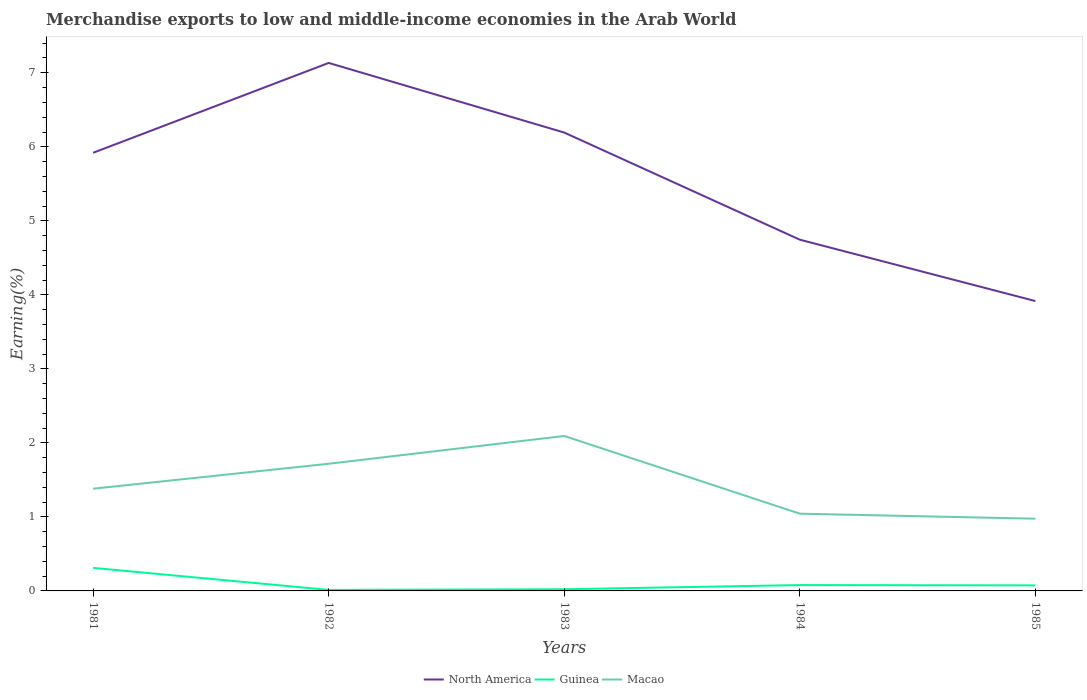Does the line corresponding to Macao intersect with the line corresponding to North America?
Provide a short and direct response. No. Across all years, what is the maximum percentage of amount earned from merchandise exports in Guinea?
Keep it short and to the point. 0.01. What is the total percentage of amount earned from merchandise exports in North America in the graph?
Offer a terse response. 0.83. What is the difference between the highest and the second highest percentage of amount earned from merchandise exports in Macao?
Your answer should be very brief. 1.12. What is the difference between the highest and the lowest percentage of amount earned from merchandise exports in Macao?
Your answer should be very brief. 2. Are the values on the major ticks of Y-axis written in scientific E-notation?
Your answer should be compact. No. Does the graph contain any zero values?
Offer a terse response. No. Does the graph contain grids?
Provide a short and direct response. No. Where does the legend appear in the graph?
Your answer should be compact. Bottom center. How many legend labels are there?
Keep it short and to the point. 3. What is the title of the graph?
Give a very brief answer. Merchandise exports to low and middle-income economies in the Arab World. Does "Bermuda" appear as one of the legend labels in the graph?
Keep it short and to the point. No. What is the label or title of the X-axis?
Make the answer very short. Years. What is the label or title of the Y-axis?
Offer a very short reply. Earning(%). What is the Earning(%) in North America in 1981?
Make the answer very short. 5.92. What is the Earning(%) of Guinea in 1981?
Offer a very short reply. 0.31. What is the Earning(%) of Macao in 1981?
Your answer should be very brief. 1.38. What is the Earning(%) of North America in 1982?
Keep it short and to the point. 7.13. What is the Earning(%) of Guinea in 1982?
Ensure brevity in your answer.  0.01. What is the Earning(%) of Macao in 1982?
Give a very brief answer. 1.72. What is the Earning(%) of North America in 1983?
Offer a terse response. 6.19. What is the Earning(%) of Guinea in 1983?
Your answer should be compact. 0.02. What is the Earning(%) in Macao in 1983?
Your answer should be compact. 2.09. What is the Earning(%) of North America in 1984?
Provide a succinct answer. 4.75. What is the Earning(%) in Guinea in 1984?
Your answer should be very brief. 0.08. What is the Earning(%) in Macao in 1984?
Offer a very short reply. 1.04. What is the Earning(%) in North America in 1985?
Keep it short and to the point. 3.92. What is the Earning(%) in Guinea in 1985?
Ensure brevity in your answer.  0.07. What is the Earning(%) of Macao in 1985?
Offer a very short reply. 0.98. Across all years, what is the maximum Earning(%) of North America?
Offer a terse response. 7.13. Across all years, what is the maximum Earning(%) of Guinea?
Provide a short and direct response. 0.31. Across all years, what is the maximum Earning(%) of Macao?
Make the answer very short. 2.09. Across all years, what is the minimum Earning(%) of North America?
Provide a short and direct response. 3.92. Across all years, what is the minimum Earning(%) of Guinea?
Provide a short and direct response. 0.01. Across all years, what is the minimum Earning(%) of Macao?
Give a very brief answer. 0.98. What is the total Earning(%) of North America in the graph?
Provide a succinct answer. 27.91. What is the total Earning(%) in Guinea in the graph?
Give a very brief answer. 0.5. What is the total Earning(%) of Macao in the graph?
Make the answer very short. 7.21. What is the difference between the Earning(%) in North America in 1981 and that in 1982?
Your answer should be compact. -1.21. What is the difference between the Earning(%) of Guinea in 1981 and that in 1982?
Provide a succinct answer. 0.3. What is the difference between the Earning(%) in Macao in 1981 and that in 1982?
Your answer should be very brief. -0.34. What is the difference between the Earning(%) of North America in 1981 and that in 1983?
Provide a succinct answer. -0.27. What is the difference between the Earning(%) of Guinea in 1981 and that in 1983?
Keep it short and to the point. 0.29. What is the difference between the Earning(%) in Macao in 1981 and that in 1983?
Provide a short and direct response. -0.71. What is the difference between the Earning(%) in North America in 1981 and that in 1984?
Your response must be concise. 1.17. What is the difference between the Earning(%) of Guinea in 1981 and that in 1984?
Provide a short and direct response. 0.23. What is the difference between the Earning(%) of Macao in 1981 and that in 1984?
Give a very brief answer. 0.34. What is the difference between the Earning(%) of North America in 1981 and that in 1985?
Offer a very short reply. 2. What is the difference between the Earning(%) in Guinea in 1981 and that in 1985?
Your response must be concise. 0.24. What is the difference between the Earning(%) in Macao in 1981 and that in 1985?
Your answer should be very brief. 0.41. What is the difference between the Earning(%) of North America in 1982 and that in 1983?
Provide a succinct answer. 0.94. What is the difference between the Earning(%) in Guinea in 1982 and that in 1983?
Your response must be concise. -0.01. What is the difference between the Earning(%) of Macao in 1982 and that in 1983?
Your answer should be very brief. -0.38. What is the difference between the Earning(%) in North America in 1982 and that in 1984?
Ensure brevity in your answer.  2.39. What is the difference between the Earning(%) in Guinea in 1982 and that in 1984?
Provide a succinct answer. -0.07. What is the difference between the Earning(%) in Macao in 1982 and that in 1984?
Give a very brief answer. 0.67. What is the difference between the Earning(%) of North America in 1982 and that in 1985?
Make the answer very short. 3.22. What is the difference between the Earning(%) of Guinea in 1982 and that in 1985?
Make the answer very short. -0.06. What is the difference between the Earning(%) of Macao in 1982 and that in 1985?
Offer a terse response. 0.74. What is the difference between the Earning(%) in North America in 1983 and that in 1984?
Provide a succinct answer. 1.45. What is the difference between the Earning(%) of Guinea in 1983 and that in 1984?
Your answer should be very brief. -0.06. What is the difference between the Earning(%) in Macao in 1983 and that in 1984?
Ensure brevity in your answer.  1.05. What is the difference between the Earning(%) in North America in 1983 and that in 1985?
Make the answer very short. 2.28. What is the difference between the Earning(%) in Guinea in 1983 and that in 1985?
Ensure brevity in your answer.  -0.05. What is the difference between the Earning(%) in Macao in 1983 and that in 1985?
Provide a short and direct response. 1.12. What is the difference between the Earning(%) of North America in 1984 and that in 1985?
Ensure brevity in your answer.  0.83. What is the difference between the Earning(%) of Guinea in 1984 and that in 1985?
Make the answer very short. 0. What is the difference between the Earning(%) in Macao in 1984 and that in 1985?
Provide a short and direct response. 0.07. What is the difference between the Earning(%) in North America in 1981 and the Earning(%) in Guinea in 1982?
Your answer should be very brief. 5.91. What is the difference between the Earning(%) in North America in 1981 and the Earning(%) in Macao in 1982?
Offer a very short reply. 4.2. What is the difference between the Earning(%) of Guinea in 1981 and the Earning(%) of Macao in 1982?
Provide a short and direct response. -1.41. What is the difference between the Earning(%) of North America in 1981 and the Earning(%) of Guinea in 1983?
Offer a very short reply. 5.9. What is the difference between the Earning(%) in North America in 1981 and the Earning(%) in Macao in 1983?
Provide a succinct answer. 3.83. What is the difference between the Earning(%) in Guinea in 1981 and the Earning(%) in Macao in 1983?
Provide a short and direct response. -1.78. What is the difference between the Earning(%) of North America in 1981 and the Earning(%) of Guinea in 1984?
Provide a succinct answer. 5.84. What is the difference between the Earning(%) of North America in 1981 and the Earning(%) of Macao in 1984?
Your response must be concise. 4.88. What is the difference between the Earning(%) of Guinea in 1981 and the Earning(%) of Macao in 1984?
Keep it short and to the point. -0.73. What is the difference between the Earning(%) in North America in 1981 and the Earning(%) in Guinea in 1985?
Offer a terse response. 5.84. What is the difference between the Earning(%) of North America in 1981 and the Earning(%) of Macao in 1985?
Your answer should be compact. 4.94. What is the difference between the Earning(%) in Guinea in 1981 and the Earning(%) in Macao in 1985?
Give a very brief answer. -0.66. What is the difference between the Earning(%) in North America in 1982 and the Earning(%) in Guinea in 1983?
Keep it short and to the point. 7.11. What is the difference between the Earning(%) in North America in 1982 and the Earning(%) in Macao in 1983?
Provide a short and direct response. 5.04. What is the difference between the Earning(%) in Guinea in 1982 and the Earning(%) in Macao in 1983?
Offer a terse response. -2.08. What is the difference between the Earning(%) of North America in 1982 and the Earning(%) of Guinea in 1984?
Ensure brevity in your answer.  7.05. What is the difference between the Earning(%) in North America in 1982 and the Earning(%) in Macao in 1984?
Give a very brief answer. 6.09. What is the difference between the Earning(%) of Guinea in 1982 and the Earning(%) of Macao in 1984?
Offer a terse response. -1.03. What is the difference between the Earning(%) in North America in 1982 and the Earning(%) in Guinea in 1985?
Give a very brief answer. 7.06. What is the difference between the Earning(%) in North America in 1982 and the Earning(%) in Macao in 1985?
Your response must be concise. 6.16. What is the difference between the Earning(%) of Guinea in 1982 and the Earning(%) of Macao in 1985?
Your answer should be compact. -0.96. What is the difference between the Earning(%) of North America in 1983 and the Earning(%) of Guinea in 1984?
Provide a succinct answer. 6.11. What is the difference between the Earning(%) in North America in 1983 and the Earning(%) in Macao in 1984?
Make the answer very short. 5.15. What is the difference between the Earning(%) of Guinea in 1983 and the Earning(%) of Macao in 1984?
Keep it short and to the point. -1.02. What is the difference between the Earning(%) of North America in 1983 and the Earning(%) of Guinea in 1985?
Your response must be concise. 6.12. What is the difference between the Earning(%) in North America in 1983 and the Earning(%) in Macao in 1985?
Offer a very short reply. 5.22. What is the difference between the Earning(%) in Guinea in 1983 and the Earning(%) in Macao in 1985?
Give a very brief answer. -0.95. What is the difference between the Earning(%) of North America in 1984 and the Earning(%) of Guinea in 1985?
Your answer should be very brief. 4.67. What is the difference between the Earning(%) in North America in 1984 and the Earning(%) in Macao in 1985?
Offer a terse response. 3.77. What is the difference between the Earning(%) in Guinea in 1984 and the Earning(%) in Macao in 1985?
Your response must be concise. -0.9. What is the average Earning(%) of North America per year?
Provide a succinct answer. 5.58. What is the average Earning(%) of Guinea per year?
Provide a succinct answer. 0.1. What is the average Earning(%) of Macao per year?
Give a very brief answer. 1.44. In the year 1981, what is the difference between the Earning(%) of North America and Earning(%) of Guinea?
Keep it short and to the point. 5.61. In the year 1981, what is the difference between the Earning(%) of North America and Earning(%) of Macao?
Offer a very short reply. 4.54. In the year 1981, what is the difference between the Earning(%) in Guinea and Earning(%) in Macao?
Provide a short and direct response. -1.07. In the year 1982, what is the difference between the Earning(%) of North America and Earning(%) of Guinea?
Offer a terse response. 7.12. In the year 1982, what is the difference between the Earning(%) of North America and Earning(%) of Macao?
Give a very brief answer. 5.42. In the year 1982, what is the difference between the Earning(%) in Guinea and Earning(%) in Macao?
Provide a succinct answer. -1.7. In the year 1983, what is the difference between the Earning(%) in North America and Earning(%) in Guinea?
Your response must be concise. 6.17. In the year 1983, what is the difference between the Earning(%) in North America and Earning(%) in Macao?
Offer a terse response. 4.1. In the year 1983, what is the difference between the Earning(%) in Guinea and Earning(%) in Macao?
Make the answer very short. -2.07. In the year 1984, what is the difference between the Earning(%) of North America and Earning(%) of Guinea?
Provide a short and direct response. 4.67. In the year 1984, what is the difference between the Earning(%) in North America and Earning(%) in Macao?
Keep it short and to the point. 3.7. In the year 1984, what is the difference between the Earning(%) of Guinea and Earning(%) of Macao?
Give a very brief answer. -0.96. In the year 1985, what is the difference between the Earning(%) of North America and Earning(%) of Guinea?
Provide a short and direct response. 3.84. In the year 1985, what is the difference between the Earning(%) in North America and Earning(%) in Macao?
Ensure brevity in your answer.  2.94. In the year 1985, what is the difference between the Earning(%) in Guinea and Earning(%) in Macao?
Provide a succinct answer. -0.9. What is the ratio of the Earning(%) of North America in 1981 to that in 1982?
Provide a succinct answer. 0.83. What is the ratio of the Earning(%) in Guinea in 1981 to that in 1982?
Provide a short and direct response. 22.32. What is the ratio of the Earning(%) of Macao in 1981 to that in 1982?
Your response must be concise. 0.8. What is the ratio of the Earning(%) in North America in 1981 to that in 1983?
Your response must be concise. 0.96. What is the ratio of the Earning(%) of Guinea in 1981 to that in 1983?
Ensure brevity in your answer.  13.79. What is the ratio of the Earning(%) in Macao in 1981 to that in 1983?
Your response must be concise. 0.66. What is the ratio of the Earning(%) in North America in 1981 to that in 1984?
Ensure brevity in your answer.  1.25. What is the ratio of the Earning(%) in Guinea in 1981 to that in 1984?
Ensure brevity in your answer.  3.93. What is the ratio of the Earning(%) in Macao in 1981 to that in 1984?
Provide a short and direct response. 1.32. What is the ratio of the Earning(%) in North America in 1981 to that in 1985?
Ensure brevity in your answer.  1.51. What is the ratio of the Earning(%) in Guinea in 1981 to that in 1985?
Offer a terse response. 4.16. What is the ratio of the Earning(%) of Macao in 1981 to that in 1985?
Offer a very short reply. 1.42. What is the ratio of the Earning(%) of North America in 1982 to that in 1983?
Provide a short and direct response. 1.15. What is the ratio of the Earning(%) in Guinea in 1982 to that in 1983?
Your answer should be very brief. 0.62. What is the ratio of the Earning(%) in Macao in 1982 to that in 1983?
Your answer should be very brief. 0.82. What is the ratio of the Earning(%) in North America in 1982 to that in 1984?
Give a very brief answer. 1.5. What is the ratio of the Earning(%) of Guinea in 1982 to that in 1984?
Offer a very short reply. 0.18. What is the ratio of the Earning(%) in Macao in 1982 to that in 1984?
Provide a short and direct response. 1.65. What is the ratio of the Earning(%) in North America in 1982 to that in 1985?
Provide a succinct answer. 1.82. What is the ratio of the Earning(%) of Guinea in 1982 to that in 1985?
Provide a succinct answer. 0.19. What is the ratio of the Earning(%) in Macao in 1982 to that in 1985?
Provide a short and direct response. 1.76. What is the ratio of the Earning(%) in North America in 1983 to that in 1984?
Give a very brief answer. 1.3. What is the ratio of the Earning(%) of Guinea in 1983 to that in 1984?
Provide a short and direct response. 0.28. What is the ratio of the Earning(%) of Macao in 1983 to that in 1984?
Your answer should be compact. 2.01. What is the ratio of the Earning(%) in North America in 1983 to that in 1985?
Give a very brief answer. 1.58. What is the ratio of the Earning(%) of Guinea in 1983 to that in 1985?
Offer a terse response. 0.3. What is the ratio of the Earning(%) in Macao in 1983 to that in 1985?
Keep it short and to the point. 2.15. What is the ratio of the Earning(%) of North America in 1984 to that in 1985?
Offer a terse response. 1.21. What is the ratio of the Earning(%) in Guinea in 1984 to that in 1985?
Make the answer very short. 1.06. What is the ratio of the Earning(%) of Macao in 1984 to that in 1985?
Your answer should be compact. 1.07. What is the difference between the highest and the second highest Earning(%) in North America?
Offer a very short reply. 0.94. What is the difference between the highest and the second highest Earning(%) in Guinea?
Provide a short and direct response. 0.23. What is the difference between the highest and the second highest Earning(%) in Macao?
Ensure brevity in your answer.  0.38. What is the difference between the highest and the lowest Earning(%) in North America?
Your answer should be compact. 3.22. What is the difference between the highest and the lowest Earning(%) of Guinea?
Provide a succinct answer. 0.3. What is the difference between the highest and the lowest Earning(%) of Macao?
Provide a succinct answer. 1.12. 